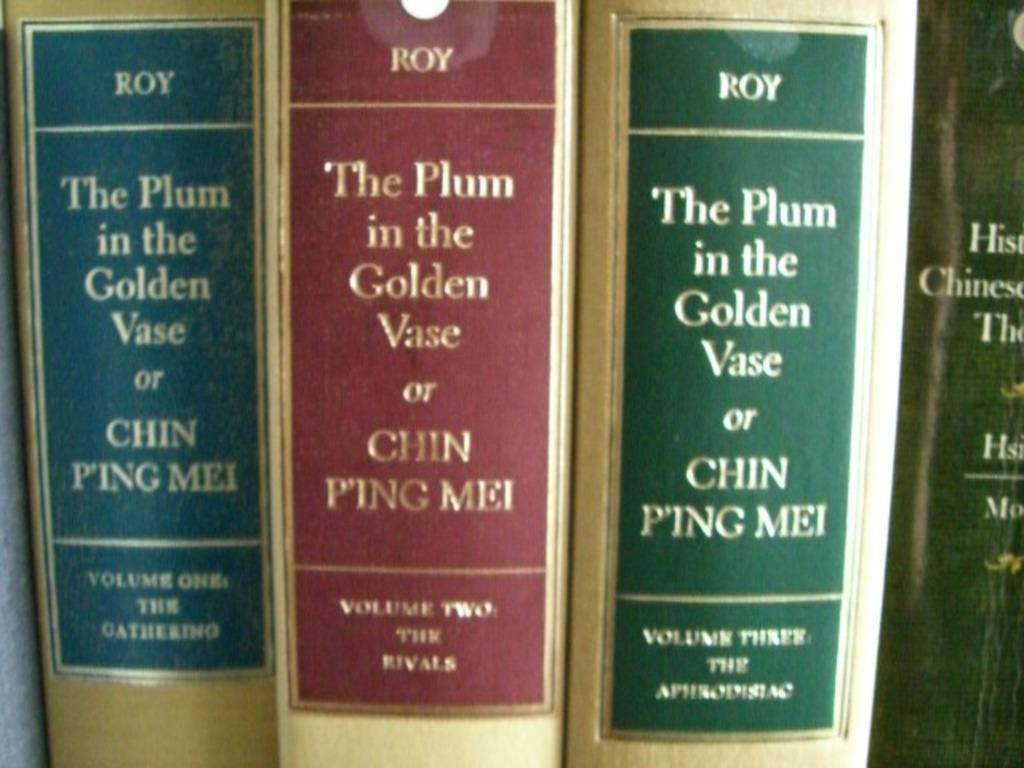<image>
Describe the image concisely. Three different colored volumes of The Plum in the Golden Vase or Chin Ping Mei are next to each other. 